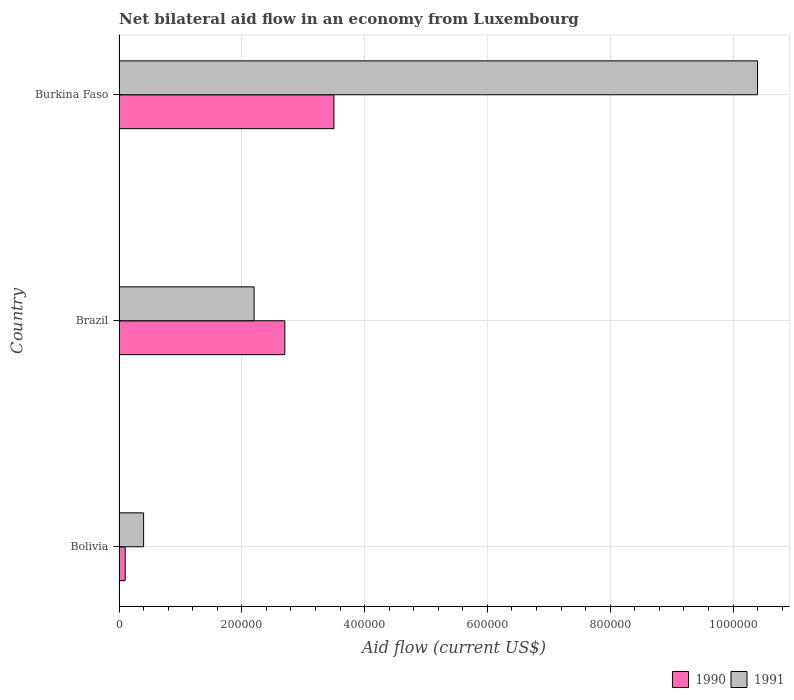How many groups of bars are there?
Your answer should be compact. 3. Are the number of bars on each tick of the Y-axis equal?
Ensure brevity in your answer.  Yes. How many bars are there on the 3rd tick from the bottom?
Provide a short and direct response. 2. What is the label of the 1st group of bars from the top?
Ensure brevity in your answer.  Burkina Faso. In how many cases, is the number of bars for a given country not equal to the number of legend labels?
Keep it short and to the point. 0. What is the net bilateral aid flow in 1990 in Burkina Faso?
Make the answer very short. 3.50e+05. Across all countries, what is the minimum net bilateral aid flow in 1990?
Give a very brief answer. 10000. In which country was the net bilateral aid flow in 1991 maximum?
Ensure brevity in your answer.  Burkina Faso. What is the total net bilateral aid flow in 1990 in the graph?
Your response must be concise. 6.30e+05. What is the difference between the net bilateral aid flow in 1991 in Brazil and that in Burkina Faso?
Keep it short and to the point. -8.20e+05. What is the average net bilateral aid flow in 1991 per country?
Give a very brief answer. 4.33e+05. In how many countries, is the net bilateral aid flow in 1991 greater than 400000 US$?
Keep it short and to the point. 1. What is the ratio of the net bilateral aid flow in 1990 in Brazil to that in Burkina Faso?
Provide a succinct answer. 0.77. Is the net bilateral aid flow in 1990 in Brazil less than that in Burkina Faso?
Your response must be concise. Yes. What is the difference between the highest and the second highest net bilateral aid flow in 1990?
Keep it short and to the point. 8.00e+04. What is the difference between the highest and the lowest net bilateral aid flow in 1991?
Ensure brevity in your answer.  1.00e+06. In how many countries, is the net bilateral aid flow in 1990 greater than the average net bilateral aid flow in 1990 taken over all countries?
Your response must be concise. 2. What does the 1st bar from the top in Brazil represents?
Provide a succinct answer. 1991. What does the 2nd bar from the bottom in Bolivia represents?
Give a very brief answer. 1991. How many countries are there in the graph?
Keep it short and to the point. 3. Does the graph contain any zero values?
Make the answer very short. No. Where does the legend appear in the graph?
Offer a terse response. Bottom right. What is the title of the graph?
Your answer should be compact. Net bilateral aid flow in an economy from Luxembourg. What is the label or title of the X-axis?
Make the answer very short. Aid flow (current US$). What is the label or title of the Y-axis?
Give a very brief answer. Country. What is the Aid flow (current US$) of 1990 in Brazil?
Your answer should be compact. 2.70e+05. What is the Aid flow (current US$) in 1991 in Brazil?
Ensure brevity in your answer.  2.20e+05. What is the Aid flow (current US$) in 1991 in Burkina Faso?
Give a very brief answer. 1.04e+06. Across all countries, what is the maximum Aid flow (current US$) of 1991?
Your answer should be compact. 1.04e+06. Across all countries, what is the minimum Aid flow (current US$) in 1991?
Provide a short and direct response. 4.00e+04. What is the total Aid flow (current US$) in 1990 in the graph?
Make the answer very short. 6.30e+05. What is the total Aid flow (current US$) of 1991 in the graph?
Ensure brevity in your answer.  1.30e+06. What is the difference between the Aid flow (current US$) in 1990 in Brazil and that in Burkina Faso?
Ensure brevity in your answer.  -8.00e+04. What is the difference between the Aid flow (current US$) in 1991 in Brazil and that in Burkina Faso?
Provide a succinct answer. -8.20e+05. What is the difference between the Aid flow (current US$) in 1990 in Bolivia and the Aid flow (current US$) in 1991 in Burkina Faso?
Your answer should be compact. -1.03e+06. What is the difference between the Aid flow (current US$) of 1990 in Brazil and the Aid flow (current US$) of 1991 in Burkina Faso?
Give a very brief answer. -7.70e+05. What is the average Aid flow (current US$) in 1991 per country?
Offer a terse response. 4.33e+05. What is the difference between the Aid flow (current US$) of 1990 and Aid flow (current US$) of 1991 in Brazil?
Provide a short and direct response. 5.00e+04. What is the difference between the Aid flow (current US$) of 1990 and Aid flow (current US$) of 1991 in Burkina Faso?
Give a very brief answer. -6.90e+05. What is the ratio of the Aid flow (current US$) of 1990 in Bolivia to that in Brazil?
Keep it short and to the point. 0.04. What is the ratio of the Aid flow (current US$) of 1991 in Bolivia to that in Brazil?
Ensure brevity in your answer.  0.18. What is the ratio of the Aid flow (current US$) of 1990 in Bolivia to that in Burkina Faso?
Ensure brevity in your answer.  0.03. What is the ratio of the Aid flow (current US$) of 1991 in Bolivia to that in Burkina Faso?
Your answer should be compact. 0.04. What is the ratio of the Aid flow (current US$) in 1990 in Brazil to that in Burkina Faso?
Your answer should be compact. 0.77. What is the ratio of the Aid flow (current US$) in 1991 in Brazil to that in Burkina Faso?
Your response must be concise. 0.21. What is the difference between the highest and the second highest Aid flow (current US$) of 1991?
Ensure brevity in your answer.  8.20e+05. What is the difference between the highest and the lowest Aid flow (current US$) in 1990?
Your answer should be compact. 3.40e+05. What is the difference between the highest and the lowest Aid flow (current US$) of 1991?
Ensure brevity in your answer.  1.00e+06. 